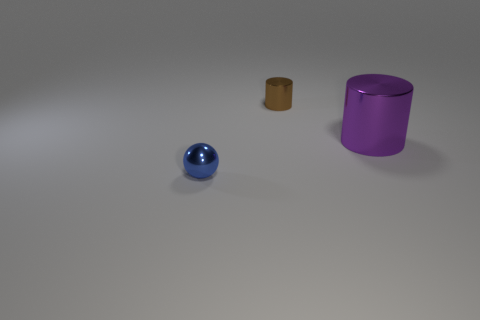There is a small blue object that is made of the same material as the brown object; what is its shape?
Your answer should be very brief. Sphere. How many small metallic balls are to the right of the tiny thing that is behind the blue sphere?
Ensure brevity in your answer.  0. How many shiny things are on the right side of the blue metal object and in front of the tiny brown shiny thing?
Give a very brief answer. 1. What number of other objects are the same material as the big purple cylinder?
Offer a very short reply. 2. What is the color of the tiny object that is to the right of the tiny thing that is in front of the large object?
Offer a very short reply. Brown. Do the ball and the brown metal cylinder have the same size?
Ensure brevity in your answer.  Yes. What is the shape of the other metal object that is the same size as the blue object?
Provide a succinct answer. Cylinder. Is the size of the metallic cylinder in front of the brown shiny object the same as the small metallic cylinder?
Give a very brief answer. No. There is a thing that is the same size as the brown shiny cylinder; what is it made of?
Your response must be concise. Metal. There is a tiny metallic thing that is in front of the metallic cylinder in front of the tiny brown shiny cylinder; are there any small things to the right of it?
Your answer should be very brief. Yes. 